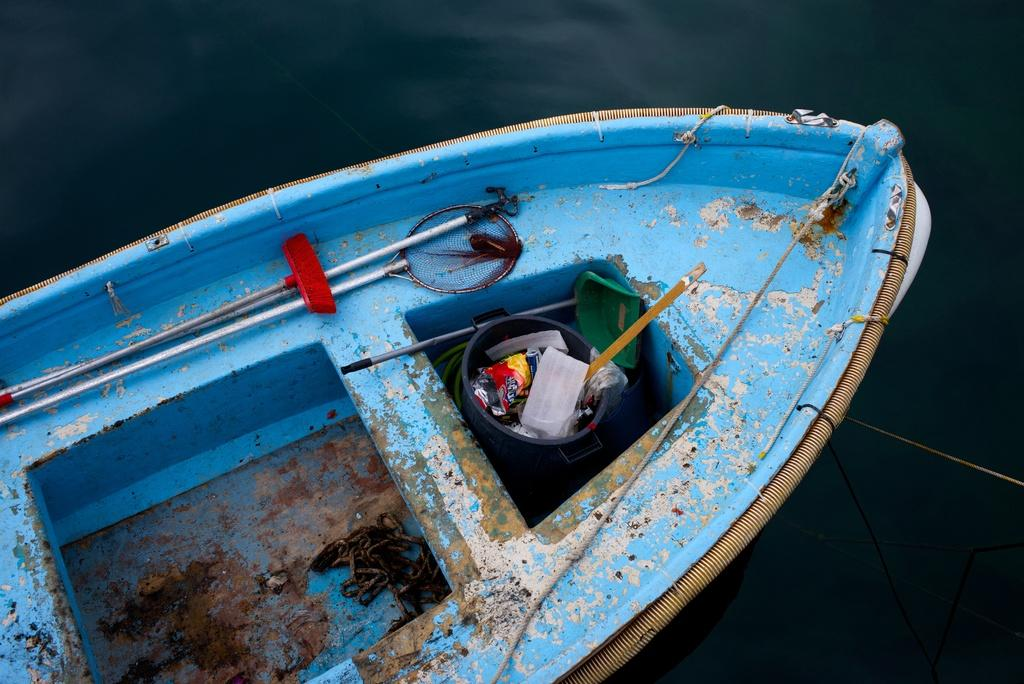What is the main subject of the image? The main subject of the image is a boat. Where is the boat located in the image? The boat is on the water surface in the image. How many mice can be seen swimming alongside the boat in the image? There are no mice present in the image; it only features a boat on the water surface. 